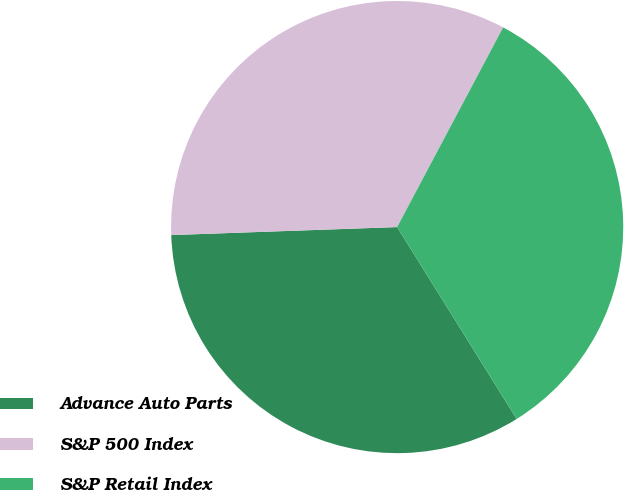<chart> <loc_0><loc_0><loc_500><loc_500><pie_chart><fcel>Advance Auto Parts<fcel>S&P 500 Index<fcel>S&P Retail Index<nl><fcel>33.3%<fcel>33.33%<fcel>33.37%<nl></chart> 